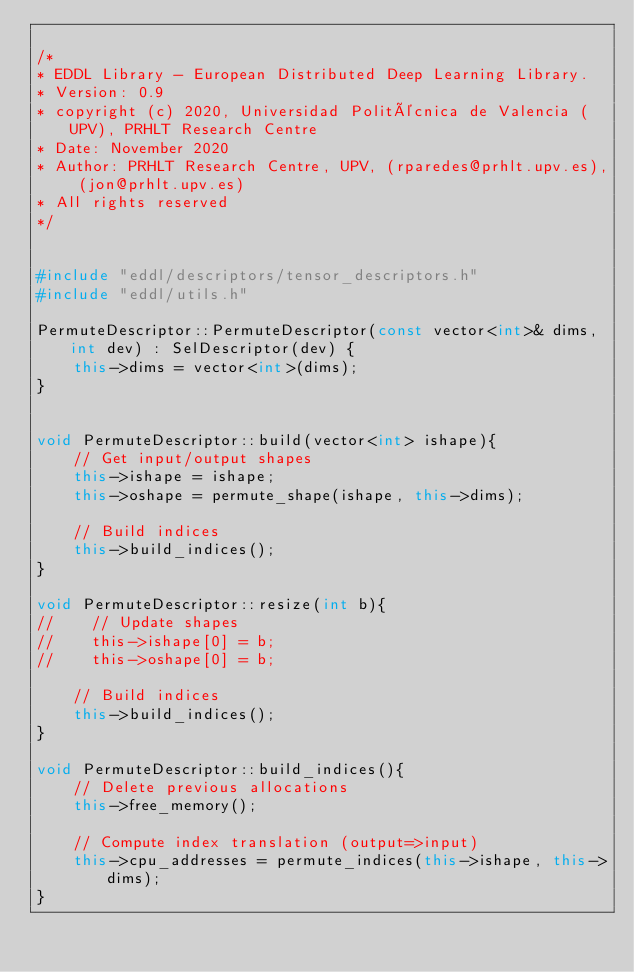Convert code to text. <code><loc_0><loc_0><loc_500><loc_500><_C++_>
/*
* EDDL Library - European Distributed Deep Learning Library.
* Version: 0.9
* copyright (c) 2020, Universidad Politécnica de Valencia (UPV), PRHLT Research Centre
* Date: November 2020
* Author: PRHLT Research Centre, UPV, (rparedes@prhlt.upv.es), (jon@prhlt.upv.es)
* All rights reserved
*/


#include "eddl/descriptors/tensor_descriptors.h"
#include "eddl/utils.h"

PermuteDescriptor::PermuteDescriptor(const vector<int>& dims, int dev) : SelDescriptor(dev) {
    this->dims = vector<int>(dims);
}


void PermuteDescriptor::build(vector<int> ishape){
    // Get input/output shapes
    this->ishape = ishape;
    this->oshape = permute_shape(ishape, this->dims);

    // Build indices
    this->build_indices();
}

void PermuteDescriptor::resize(int b){
//    // Update shapes
//    this->ishape[0] = b;
//    this->oshape[0] = b;

    // Build indices
    this->build_indices();
}

void PermuteDescriptor::build_indices(){
    // Delete previous allocations
    this->free_memory();

    // Compute index translation (output=>input)
    this->cpu_addresses = permute_indices(this->ishape, this->dims);
}
</code> 